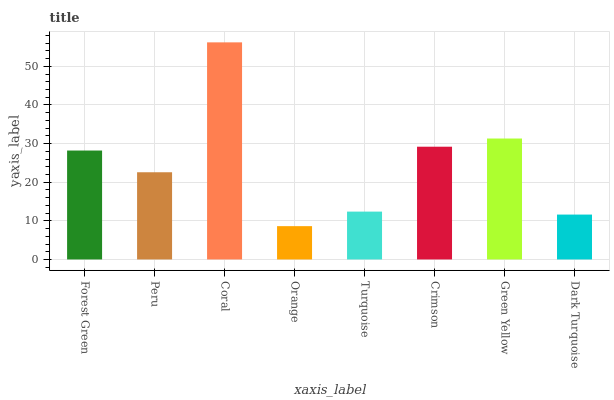Is Orange the minimum?
Answer yes or no. Yes. Is Coral the maximum?
Answer yes or no. Yes. Is Peru the minimum?
Answer yes or no. No. Is Peru the maximum?
Answer yes or no. No. Is Forest Green greater than Peru?
Answer yes or no. Yes. Is Peru less than Forest Green?
Answer yes or no. Yes. Is Peru greater than Forest Green?
Answer yes or no. No. Is Forest Green less than Peru?
Answer yes or no. No. Is Forest Green the high median?
Answer yes or no. Yes. Is Peru the low median?
Answer yes or no. Yes. Is Peru the high median?
Answer yes or no. No. Is Orange the low median?
Answer yes or no. No. 